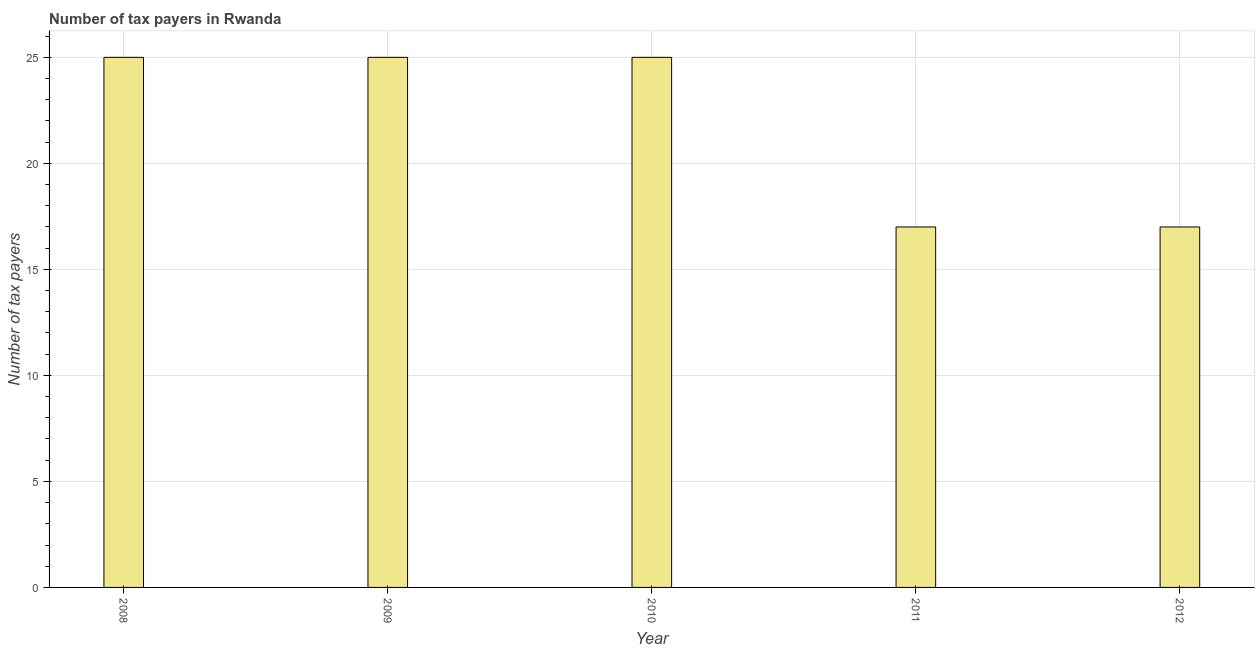Does the graph contain any zero values?
Your answer should be compact. No. Does the graph contain grids?
Offer a very short reply. Yes. What is the title of the graph?
Offer a terse response. Number of tax payers in Rwanda. What is the label or title of the X-axis?
Offer a terse response. Year. What is the label or title of the Y-axis?
Give a very brief answer. Number of tax payers. What is the number of tax payers in 2012?
Keep it short and to the point. 17. Across all years, what is the maximum number of tax payers?
Ensure brevity in your answer.  25. In which year was the number of tax payers minimum?
Make the answer very short. 2011. What is the sum of the number of tax payers?
Your answer should be very brief. 109. What is the median number of tax payers?
Offer a terse response. 25. What is the ratio of the number of tax payers in 2009 to that in 2012?
Your answer should be very brief. 1.47. Is the difference between the number of tax payers in 2009 and 2011 greater than the difference between any two years?
Give a very brief answer. Yes. What is the difference between the highest and the second highest number of tax payers?
Make the answer very short. 0. Is the sum of the number of tax payers in 2008 and 2011 greater than the maximum number of tax payers across all years?
Offer a terse response. Yes. In how many years, is the number of tax payers greater than the average number of tax payers taken over all years?
Your answer should be compact. 3. Are all the bars in the graph horizontal?
Give a very brief answer. No. What is the difference between two consecutive major ticks on the Y-axis?
Offer a terse response. 5. What is the Number of tax payers in 2009?
Provide a succinct answer. 25. What is the Number of tax payers in 2012?
Offer a very short reply. 17. What is the difference between the Number of tax payers in 2008 and 2009?
Offer a very short reply. 0. What is the difference between the Number of tax payers in 2008 and 2010?
Your answer should be very brief. 0. What is the difference between the Number of tax payers in 2008 and 2011?
Ensure brevity in your answer.  8. What is the difference between the Number of tax payers in 2008 and 2012?
Give a very brief answer. 8. What is the difference between the Number of tax payers in 2009 and 2011?
Your answer should be very brief. 8. What is the difference between the Number of tax payers in 2009 and 2012?
Offer a very short reply. 8. What is the difference between the Number of tax payers in 2011 and 2012?
Offer a terse response. 0. What is the ratio of the Number of tax payers in 2008 to that in 2009?
Ensure brevity in your answer.  1. What is the ratio of the Number of tax payers in 2008 to that in 2011?
Your response must be concise. 1.47. What is the ratio of the Number of tax payers in 2008 to that in 2012?
Make the answer very short. 1.47. What is the ratio of the Number of tax payers in 2009 to that in 2010?
Your response must be concise. 1. What is the ratio of the Number of tax payers in 2009 to that in 2011?
Ensure brevity in your answer.  1.47. What is the ratio of the Number of tax payers in 2009 to that in 2012?
Ensure brevity in your answer.  1.47. What is the ratio of the Number of tax payers in 2010 to that in 2011?
Your answer should be compact. 1.47. What is the ratio of the Number of tax payers in 2010 to that in 2012?
Keep it short and to the point. 1.47. What is the ratio of the Number of tax payers in 2011 to that in 2012?
Your answer should be compact. 1. 